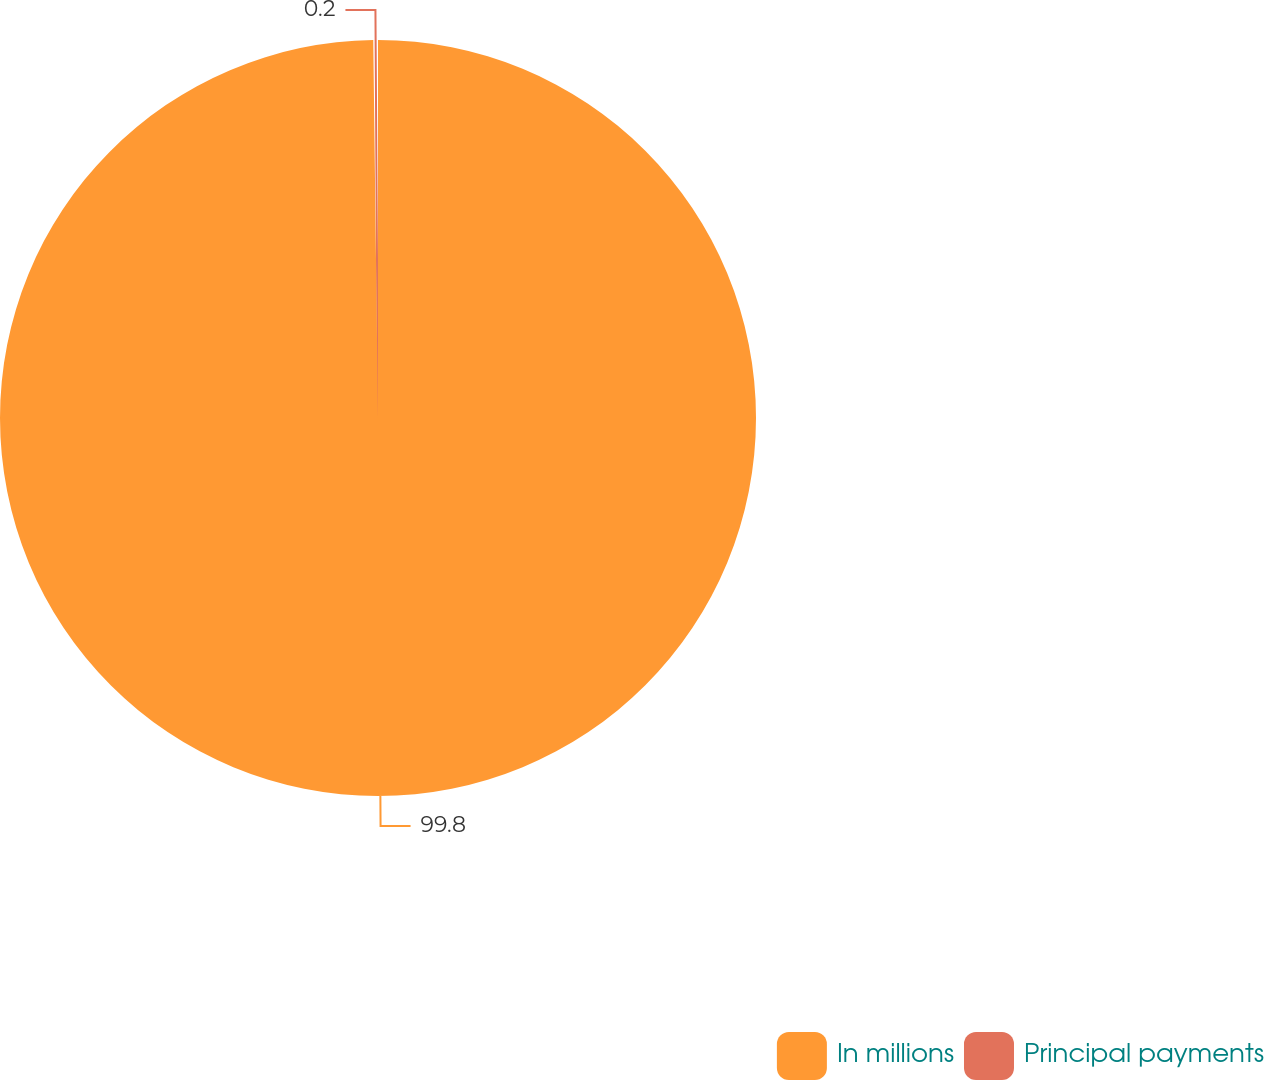Convert chart to OTSL. <chart><loc_0><loc_0><loc_500><loc_500><pie_chart><fcel>In millions<fcel>Principal payments<nl><fcel>99.8%<fcel>0.2%<nl></chart> 